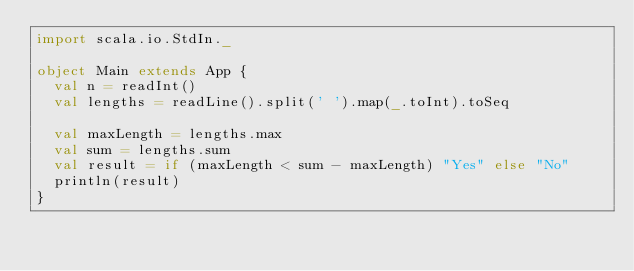Convert code to text. <code><loc_0><loc_0><loc_500><loc_500><_Scala_>import scala.io.StdIn._

object Main extends App {
  val n = readInt()
  val lengths = readLine().split(' ').map(_.toInt).toSeq
  
  val maxLength = lengths.max
  val sum = lengths.sum
  val result = if (maxLength < sum - maxLength) "Yes" else "No"
  println(result)
}</code> 